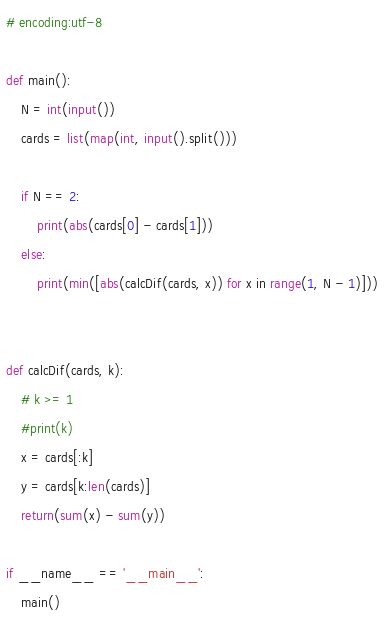Convert code to text. <code><loc_0><loc_0><loc_500><loc_500><_Python_># encoding:utf-8

def main():
	N = int(input())
	cards = list(map(int, input().split()))

	if N == 2:
		print(abs(cards[0] - cards[1]))
	else:
		print(min([abs(calcDif(cards, x)) for x in range(1, N - 1)]))


def calcDif(cards, k):
	# k >= 1
	#print(k)
	x = cards[:k]
	y = cards[k:len(cards)]
	return(sum(x) - sum(y))

if __name__ == '__main__':
	main()</code> 